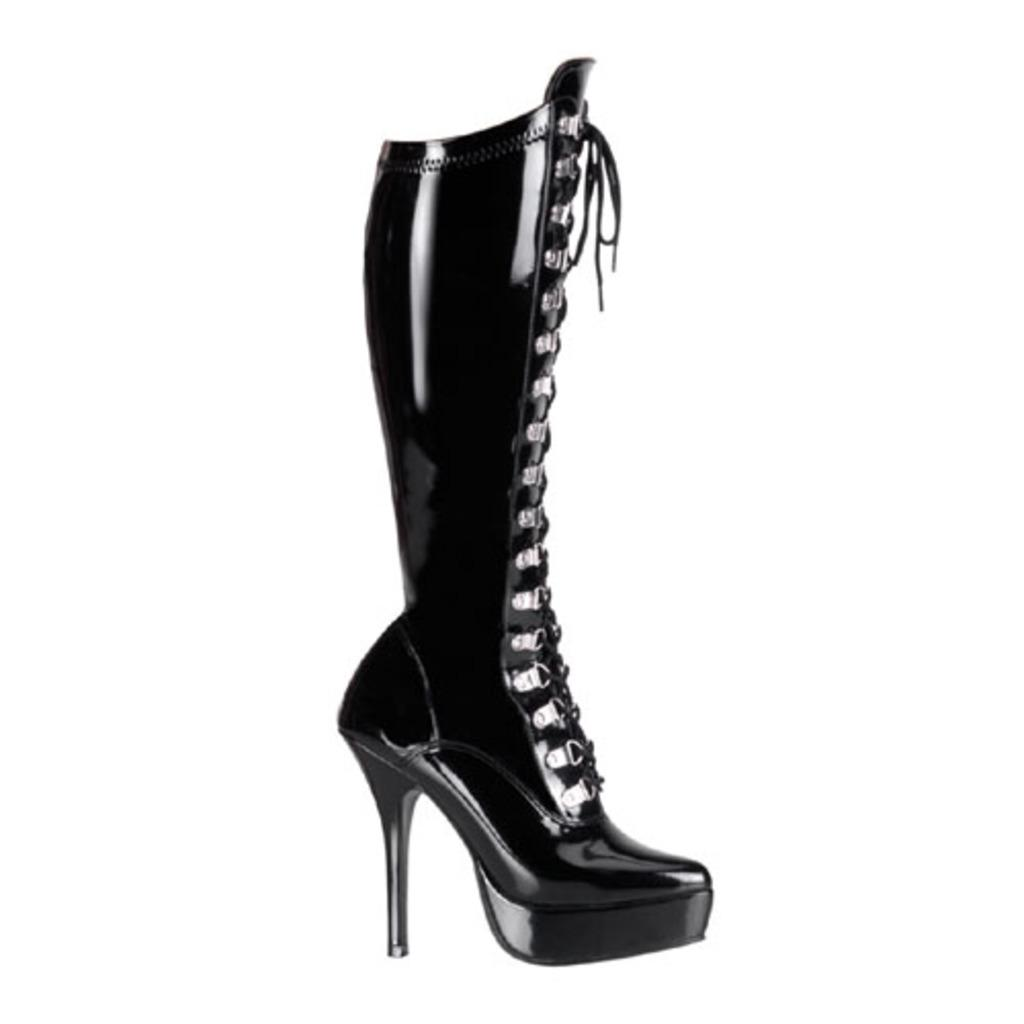What type of shoe is featured in the image? There is a black color shoe model in the image. What kind of heel does the shoe have? The shoe model is a heel. What color is the background of the image? The background of the image is white. How does the shoe model contribute to pollution in the image? The shoe model does not contribute to pollution in the image, as it is an inanimate object and there is no indication of pollution in the image. 